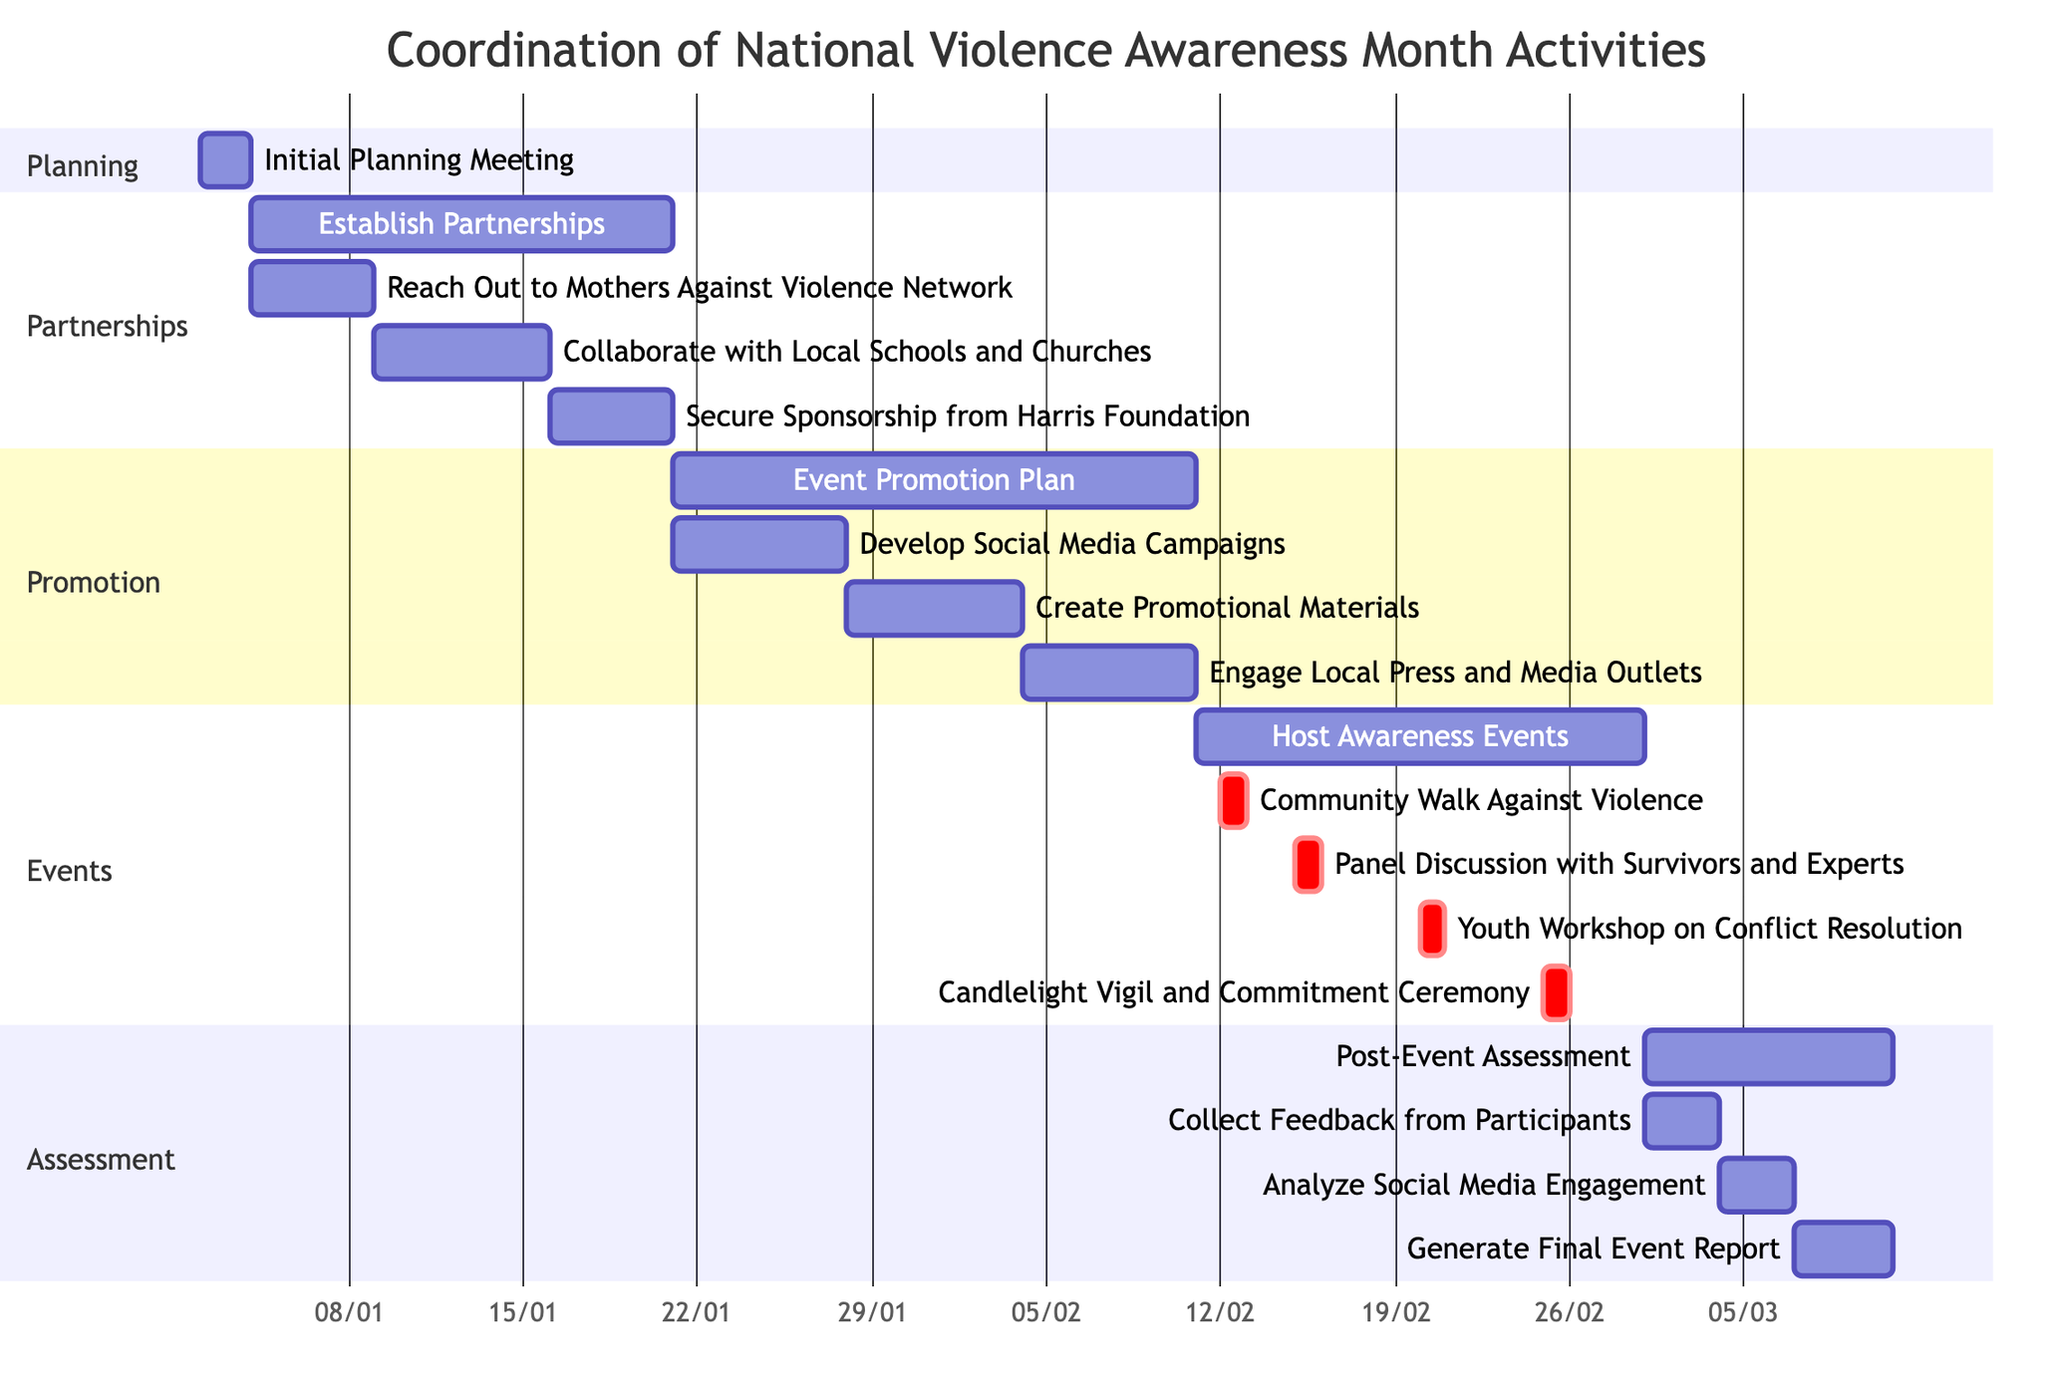What is the duration of the "Initial Planning Meeting"? The "Initial Planning Meeting" starts on January 2, 2023, and ends on January 3, 2023, which totals to 2 days.
Answer: 2d How many subtasks are listed under "Establish Partnerships"? There are three subtasks listed under "Establish Partnerships": Reach Out to Mothers Against Violence Network, Collaborate with Local Schools and Churches, and Secure Sponsorship from Harris Foundation.
Answer: 3 What event occurs immediately after "Community Walk Against Violence"? After the "Community Walk Against Violence," the next event scheduled is the "Panel Discussion with Survivors and Experts." This event is listed directly under the same timeframe.
Answer: Panel Discussion with Survivors and Experts What is the start date of the "Event Promotion Plan"? The "Event Promotion Plan" starts on January 21, 2023, according to the diagram timeline.
Answer: 2023-01-21 Which task has the longest duration in the diagram? The "Establish Partnerships" task has the longest duration. It lasts for 17 days from January 4, 2023, to January 20, 2023.
Answer: 17d How many days are allocated for "Post-Event Assessment"? The "Post-Event Assessment" is allocated 10 days, starting from March 1, 2023, to March 10, 2023.
Answer: 10d What task is scheduled on the same day as the "Youth Workshop on Conflict Resolution"? The "Youth Workshop on Conflict Resolution" is scheduled on February 20, 2023, and does not share the same day with any other task as it is a unique task on that date.
Answer: None What is the end date for "Engage Local Press and Media Outlets"? The "Engage Local Press and Media Outlets" task ends on February 10, 2023, marking the completion of that phase of the events.
Answer: 2023-02-10 How many primary sections are in the diagram? The diagram contains four primary sections: Planning, Partnerships, Promotion, Events, and Assessment, which categorize the tasks accordingly.
Answer: 5 